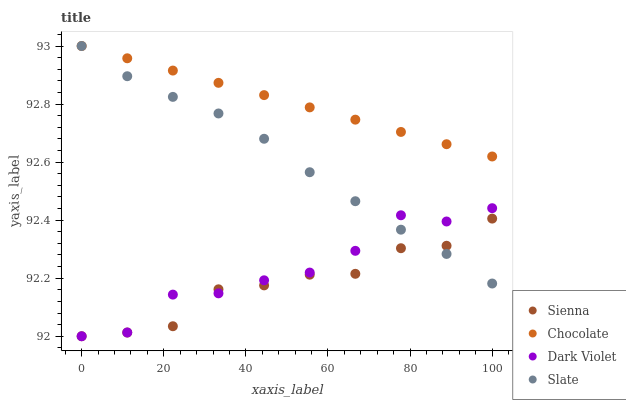Does Sienna have the minimum area under the curve?
Answer yes or no. Yes. Does Chocolate have the maximum area under the curve?
Answer yes or no. Yes. Does Slate have the minimum area under the curve?
Answer yes or no. No. Does Slate have the maximum area under the curve?
Answer yes or no. No. Is Chocolate the smoothest?
Answer yes or no. Yes. Is Dark Violet the roughest?
Answer yes or no. Yes. Is Slate the smoothest?
Answer yes or no. No. Is Slate the roughest?
Answer yes or no. No. Does Sienna have the lowest value?
Answer yes or no. Yes. Does Slate have the lowest value?
Answer yes or no. No. Does Chocolate have the highest value?
Answer yes or no. Yes. Does Dark Violet have the highest value?
Answer yes or no. No. Is Dark Violet less than Chocolate?
Answer yes or no. Yes. Is Chocolate greater than Dark Violet?
Answer yes or no. Yes. Does Chocolate intersect Slate?
Answer yes or no. Yes. Is Chocolate less than Slate?
Answer yes or no. No. Is Chocolate greater than Slate?
Answer yes or no. No. Does Dark Violet intersect Chocolate?
Answer yes or no. No. 